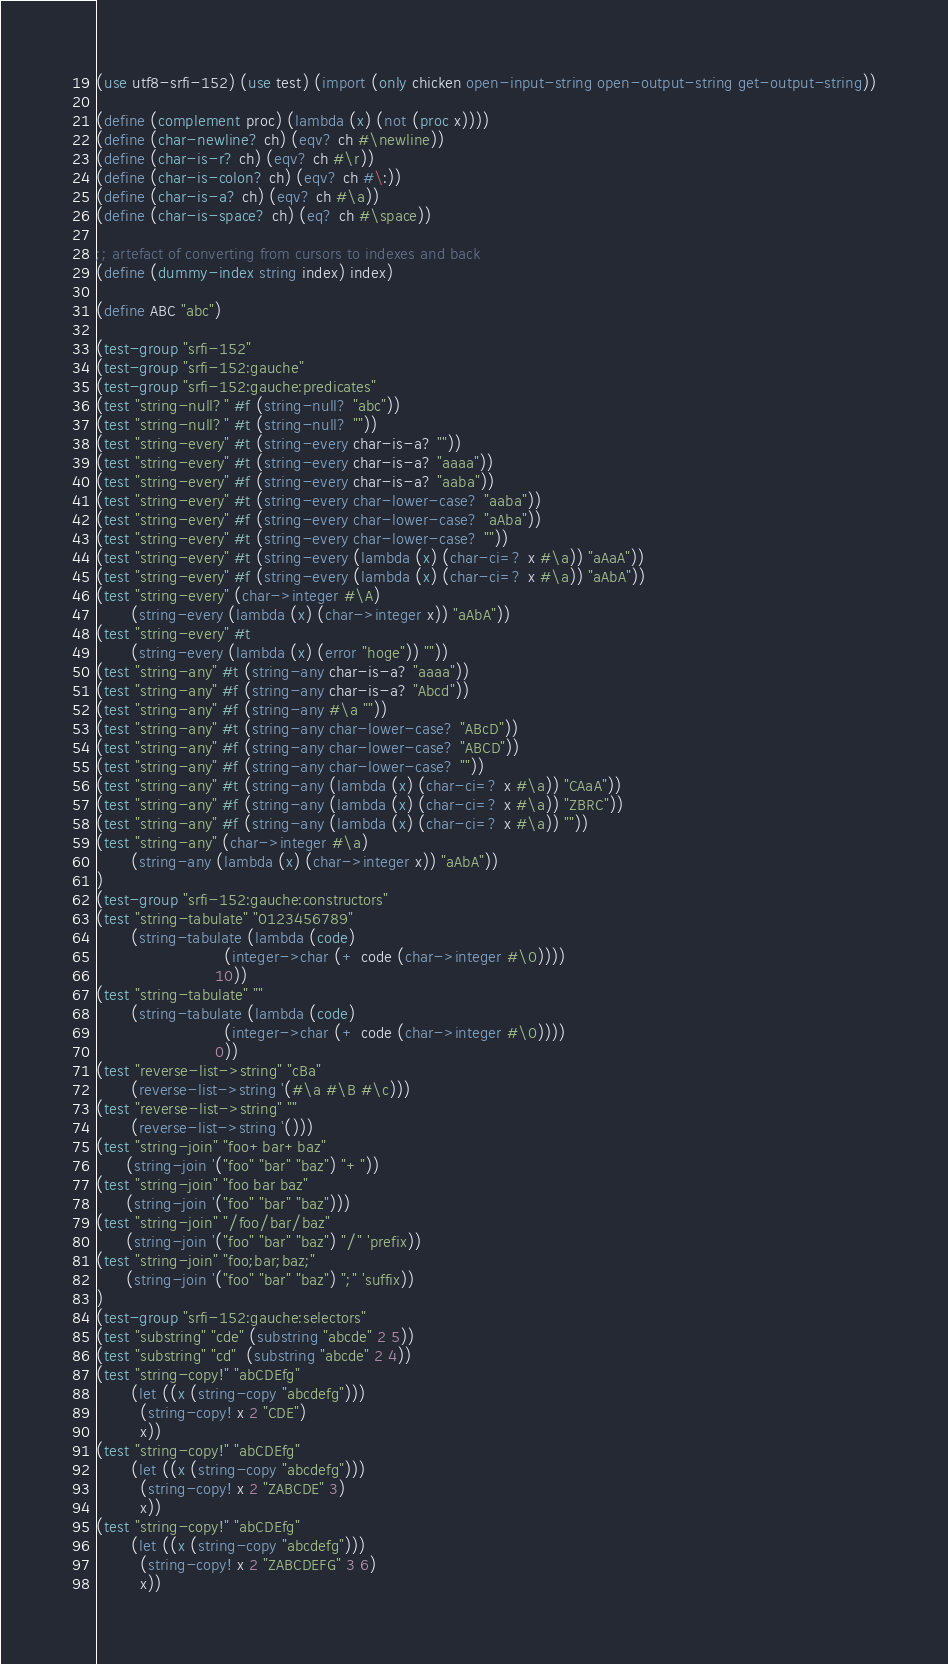Convert code to text. <code><loc_0><loc_0><loc_500><loc_500><_Scheme_>(use utf8-srfi-152) (use test) (import (only chicken open-input-string open-output-string get-output-string))

(define (complement proc) (lambda (x) (not (proc x))))
(define (char-newline? ch) (eqv? ch #\newline))
(define (char-is-r? ch) (eqv? ch #\r))
(define (char-is-colon? ch) (eqv? ch #\:))
(define (char-is-a? ch) (eqv? ch #\a))
(define (char-is-space? ch) (eq? ch #\space))

;; artefact of converting from cursors to indexes and back
(define (dummy-index string index) index)

(define ABC "abc")

(test-group "srfi-152"
(test-group "srfi-152:gauche"
(test-group "srfi-152:gauche:predicates"
(test "string-null?" #f (string-null? "abc"))
(test "string-null?" #t (string-null? ""))
(test "string-every" #t (string-every char-is-a? ""))
(test "string-every" #t (string-every char-is-a? "aaaa"))
(test "string-every" #f (string-every char-is-a? "aaba"))
(test "string-every" #t (string-every char-lower-case? "aaba"))
(test "string-every" #f (string-every char-lower-case? "aAba"))
(test "string-every" #t (string-every char-lower-case? ""))
(test "string-every" #t (string-every (lambda (x) (char-ci=? x #\a)) "aAaA"))
(test "string-every" #f (string-every (lambda (x) (char-ci=? x #\a)) "aAbA"))
(test "string-every" (char->integer #\A)
       (string-every (lambda (x) (char->integer x)) "aAbA"))
(test "string-every" #t
       (string-every (lambda (x) (error "hoge")) ""))
(test "string-any" #t (string-any char-is-a? "aaaa"))
(test "string-any" #f (string-any char-is-a? "Abcd"))
(test "string-any" #f (string-any #\a ""))
(test "string-any" #t (string-any char-lower-case? "ABcD"))
(test "string-any" #f (string-any char-lower-case? "ABCD"))
(test "string-any" #f (string-any char-lower-case? ""))
(test "string-any" #t (string-any (lambda (x) (char-ci=? x #\a)) "CAaA"))
(test "string-any" #f (string-any (lambda (x) (char-ci=? x #\a)) "ZBRC"))
(test "string-any" #f (string-any (lambda (x) (char-ci=? x #\a)) ""))
(test "string-any" (char->integer #\a)
       (string-any (lambda (x) (char->integer x)) "aAbA"))
)
(test-group "srfi-152:gauche:constructors"
(test "string-tabulate" "0123456789"
       (string-tabulate (lambda (code)
                          (integer->char (+ code (char->integer #\0))))
                        10))
(test "string-tabulate" ""
       (string-tabulate (lambda (code)
                          (integer->char (+ code (char->integer #\0))))
                        0))
(test "reverse-list->string" "cBa"
       (reverse-list->string '(#\a #\B #\c)))
(test "reverse-list->string" ""
       (reverse-list->string '()))
(test "string-join" "foo+bar+baz"
      (string-join '("foo" "bar" "baz") "+"))
(test "string-join" "foo bar baz"
      (string-join '("foo" "bar" "baz")))
(test "string-join" "/foo/bar/baz"
      (string-join '("foo" "bar" "baz") "/" 'prefix))
(test "string-join" "foo;bar;baz;"
      (string-join '("foo" "bar" "baz") ";" 'suffix))
)
(test-group "srfi-152:gauche:selectors"
(test "substring" "cde" (substring "abcde" 2 5))
(test "substring" "cd"  (substring "abcde" 2 4))
(test "string-copy!" "abCDEfg"
       (let ((x (string-copy "abcdefg")))
         (string-copy! x 2 "CDE")
         x))
(test "string-copy!" "abCDEfg"
       (let ((x (string-copy "abcdefg")))
         (string-copy! x 2 "ZABCDE" 3)
         x))
(test "string-copy!" "abCDEfg"
       (let ((x (string-copy "abcdefg")))
         (string-copy! x 2 "ZABCDEFG" 3 6)
         x))</code> 